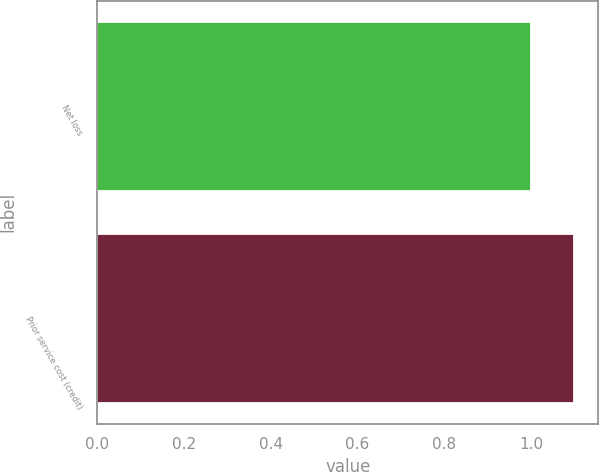<chart> <loc_0><loc_0><loc_500><loc_500><bar_chart><fcel>Net loss<fcel>Prior service cost (credit)<nl><fcel>1<fcel>1.1<nl></chart> 